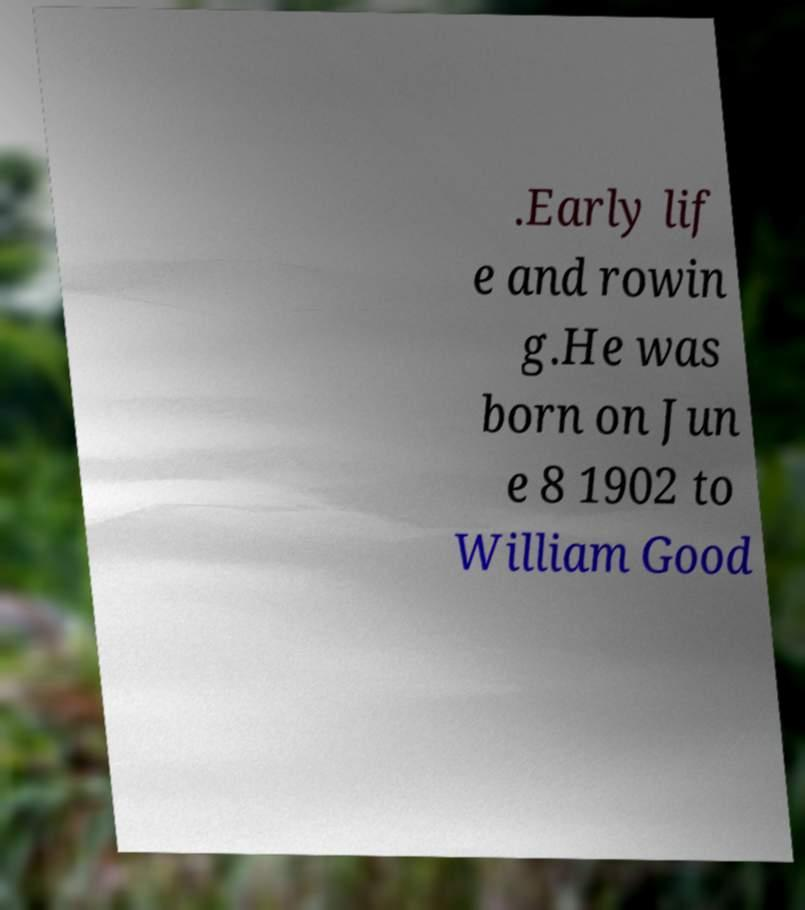Could you extract and type out the text from this image? .Early lif e and rowin g.He was born on Jun e 8 1902 to William Good 